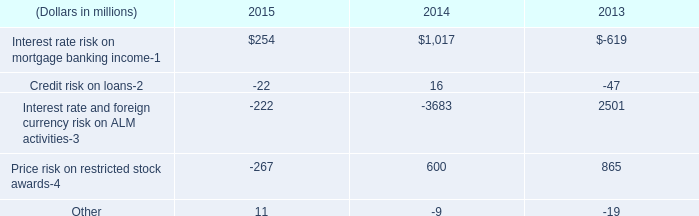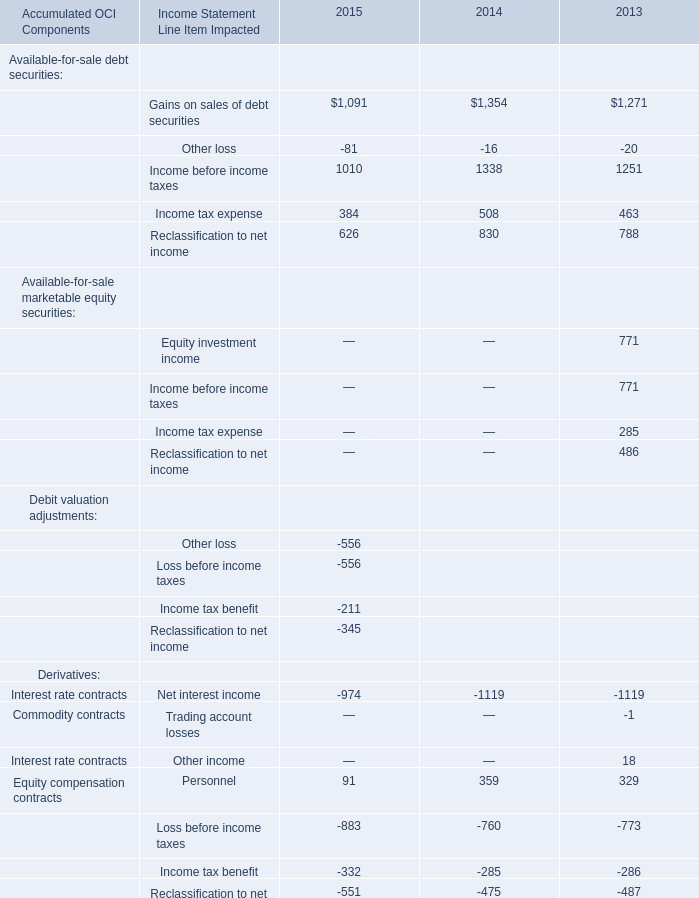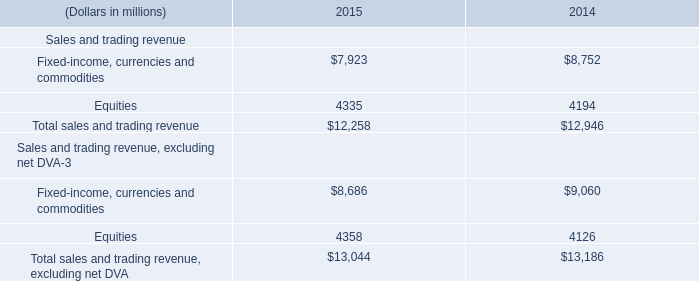What's the total amount of the Interest rate risk on mortgage banking income in the years whereFixed-income, currencies and commodities is greater than 7900 (in million) 
Computations: (254 + 1017)
Answer: 1271.0. 